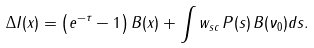<formula> <loc_0><loc_0><loc_500><loc_500>\Delta I ( x ) = \left ( e ^ { - \tau } - 1 \right ) B ( x ) + \int w _ { s c } \, P ( s ) \, B ( \nu _ { 0 } ) d s .</formula> 